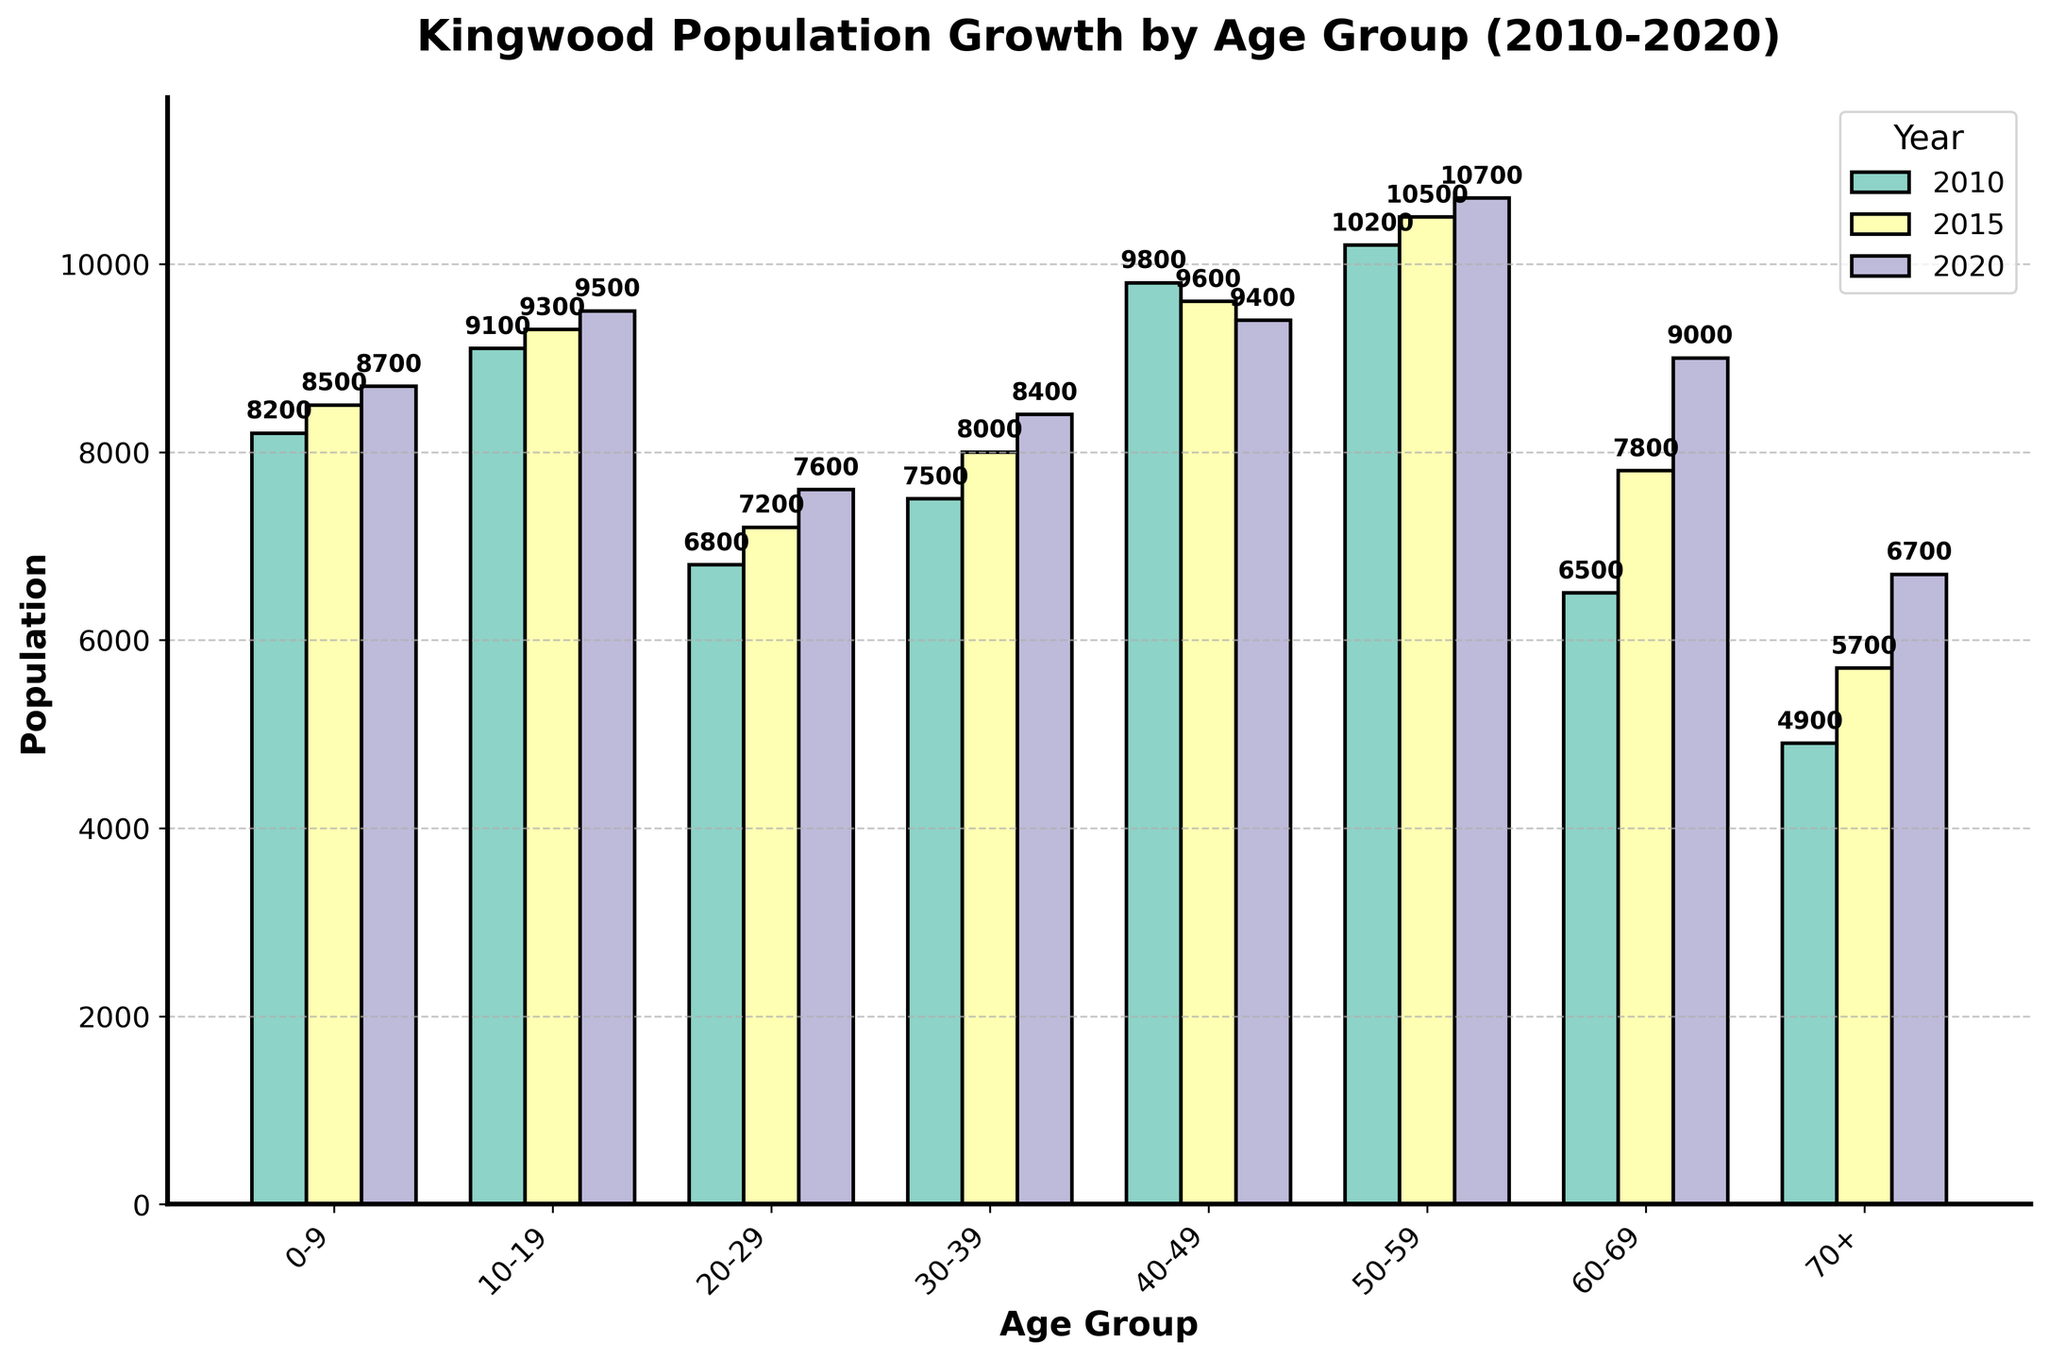What is the population of the 30-39 age group in 2020? Refer to the 2020 bar for the 30-39 age group and read the population value displayed.
Answer: 8,400 Which age group had the highest population in 2020? Compare the heights of the bars for the year 2020 for all age groups and identify the highest one.
Answer: 50-59 How much did the population of the 60-69 age group increase from 2010 to 2020? Subtract the 2010 value of the 60-69 age group from its 2020 value (9000 - 6500).
Answer: 2,500 What is the total population of all age groups for the year 2015? Sum up the populations of all age groups for the year 2015 (8500 + 9300 + 7200 + 8000 + 9600 + 10500 + 7800 + 5700).
Answer: 66,600 Which age group saw the smallest population change between 2010 and 2020? Calculate the absolute differences in population for each age group between 2010 and 2020 and identify the smallest one: (8700-8200, 9500-9100, 7600-6800, etc.).
Answer: 0-9 Among the 10-19 age group, how much did the population grow from 2010 to 2015, and then to 2020? Calculate the differences for each period: (9300 - 9100) and (9500 - 9300).
Answer: 200, 200 Which bars are colored green and what year do they represent? Identify the color of the bars for each year; note that the year represented by green is 2010.
Answer: 2010 Is the 70+ age group's population in 2020 greater than the 20-29 age group's population in 2010? Compare the height of the 70+ age group bar in 2020 with the 20-29 age group bar in 2010 (6700 > 6800).
Answer: No 